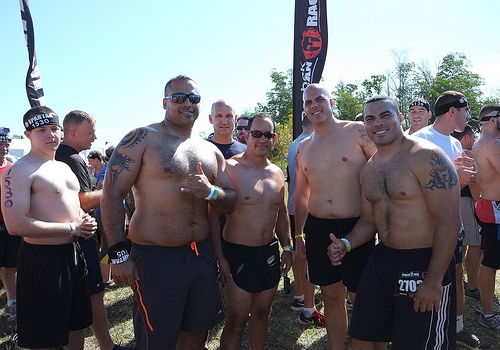<image>
Can you confirm if the tree is behind the man? Yes. From this viewpoint, the tree is positioned behind the man, with the man partially or fully occluding the tree. 